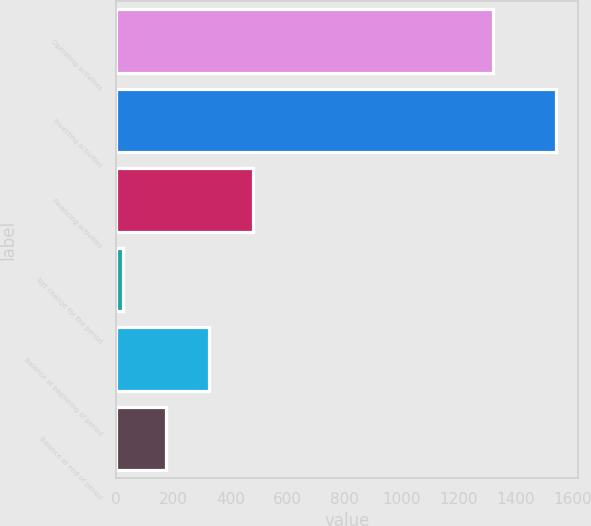<chart> <loc_0><loc_0><loc_500><loc_500><bar_chart><fcel>Operating activities<fcel>Investing activities<fcel>Financing activities<fcel>Net change for the period<fcel>Balance at beginning of period<fcel>Balance at end of period<nl><fcel>1320<fcel>1540<fcel>478.1<fcel>23<fcel>326.4<fcel>174.7<nl></chart> 